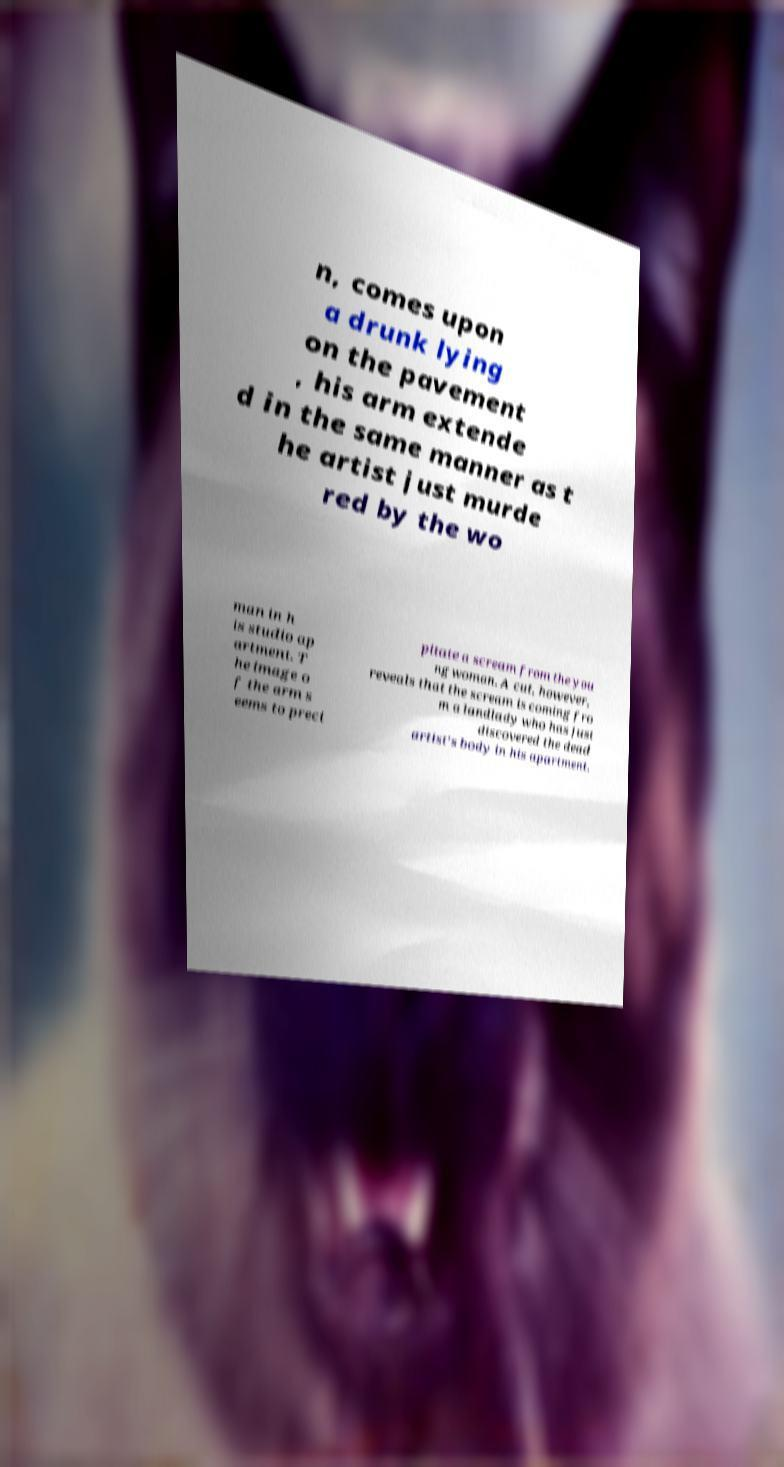Can you accurately transcribe the text from the provided image for me? n, comes upon a drunk lying on the pavement , his arm extende d in the same manner as t he artist just murde red by the wo man in h is studio ap artment. T he image o f the arm s eems to preci pitate a scream from the you ng woman. A cut, however, reveals that the scream is coming fro m a landlady who has just discovered the dead artist's body in his apartment. 